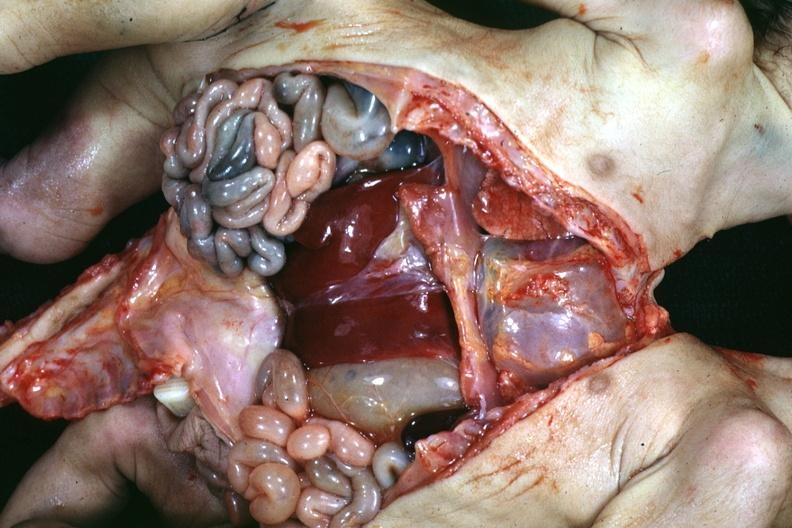what is present?
Answer the question using a single word or phrase. Siamese twins 